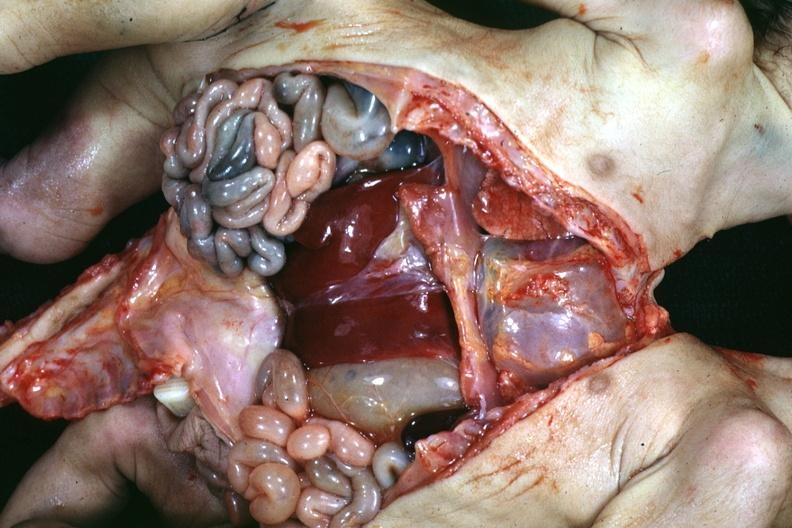what is present?
Answer the question using a single word or phrase. Siamese twins 